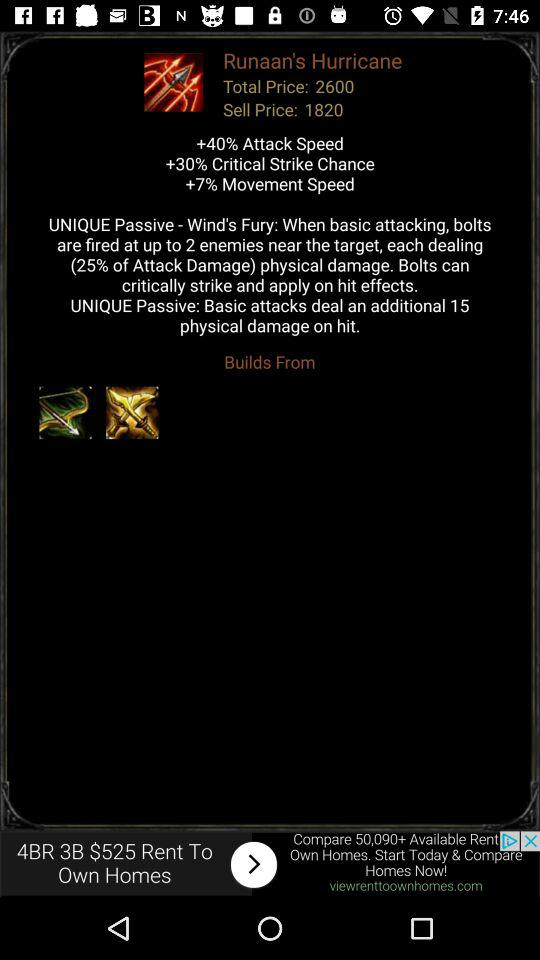What is the percentage of attack speed? The percentage of attack speed is 40. 